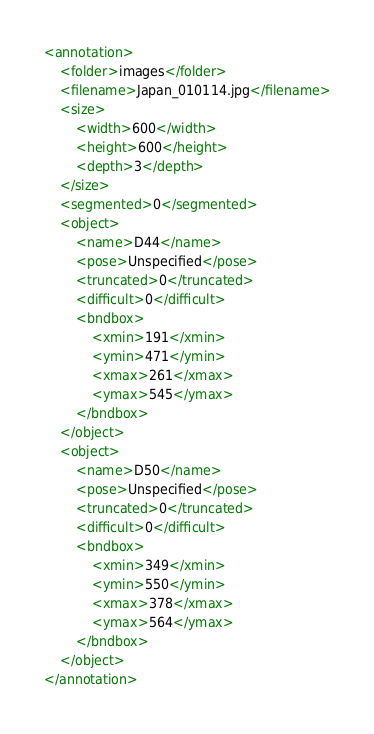<code> <loc_0><loc_0><loc_500><loc_500><_XML_><annotation>
	<folder>images</folder>
	<filename>Japan_010114.jpg</filename>
	<size>
		<width>600</width>
		<height>600</height>
		<depth>3</depth>
	</size>
	<segmented>0</segmented>
	<object>
		<name>D44</name>
		<pose>Unspecified</pose>
		<truncated>0</truncated>
		<difficult>0</difficult>
		<bndbox>
			<xmin>191</xmin>
			<ymin>471</ymin>
			<xmax>261</xmax>
			<ymax>545</ymax>
		</bndbox>
	</object>
	<object>
		<name>D50</name>
		<pose>Unspecified</pose>
		<truncated>0</truncated>
		<difficult>0</difficult>
		<bndbox>
			<xmin>349</xmin>
			<ymin>550</ymin>
			<xmax>378</xmax>
			<ymax>564</ymax>
		</bndbox>
	</object>
</annotation></code> 